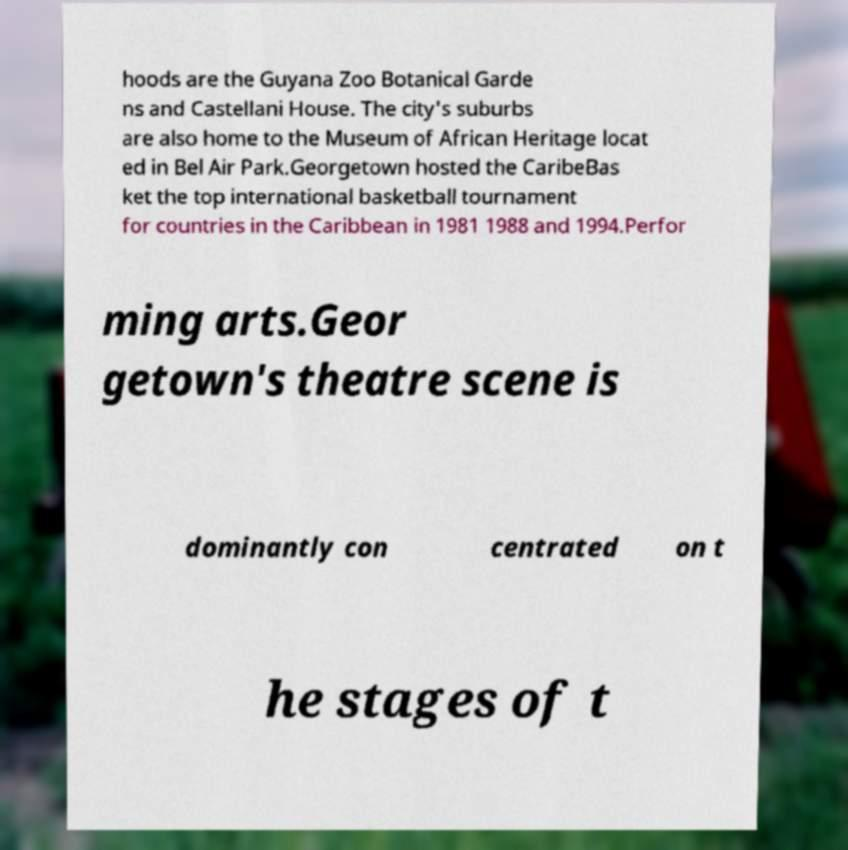I need the written content from this picture converted into text. Can you do that? hoods are the Guyana Zoo Botanical Garde ns and Castellani House. The city's suburbs are also home to the Museum of African Heritage locat ed in Bel Air Park.Georgetown hosted the CaribeBas ket the top international basketball tournament for countries in the Caribbean in 1981 1988 and 1994.Perfor ming arts.Geor getown's theatre scene is dominantly con centrated on t he stages of t 